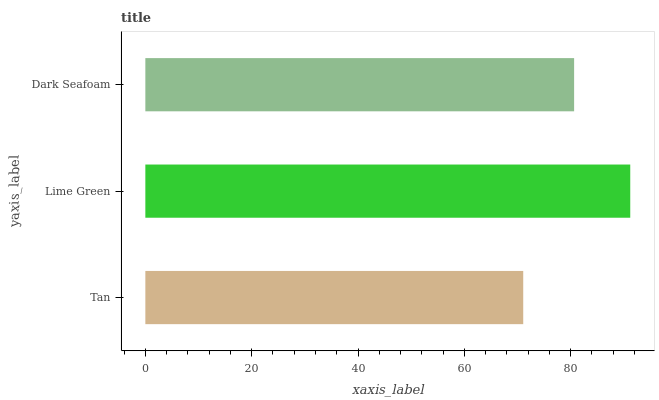Is Tan the minimum?
Answer yes or no. Yes. Is Lime Green the maximum?
Answer yes or no. Yes. Is Dark Seafoam the minimum?
Answer yes or no. No. Is Dark Seafoam the maximum?
Answer yes or no. No. Is Lime Green greater than Dark Seafoam?
Answer yes or no. Yes. Is Dark Seafoam less than Lime Green?
Answer yes or no. Yes. Is Dark Seafoam greater than Lime Green?
Answer yes or no. No. Is Lime Green less than Dark Seafoam?
Answer yes or no. No. Is Dark Seafoam the high median?
Answer yes or no. Yes. Is Dark Seafoam the low median?
Answer yes or no. Yes. Is Tan the high median?
Answer yes or no. No. Is Tan the low median?
Answer yes or no. No. 